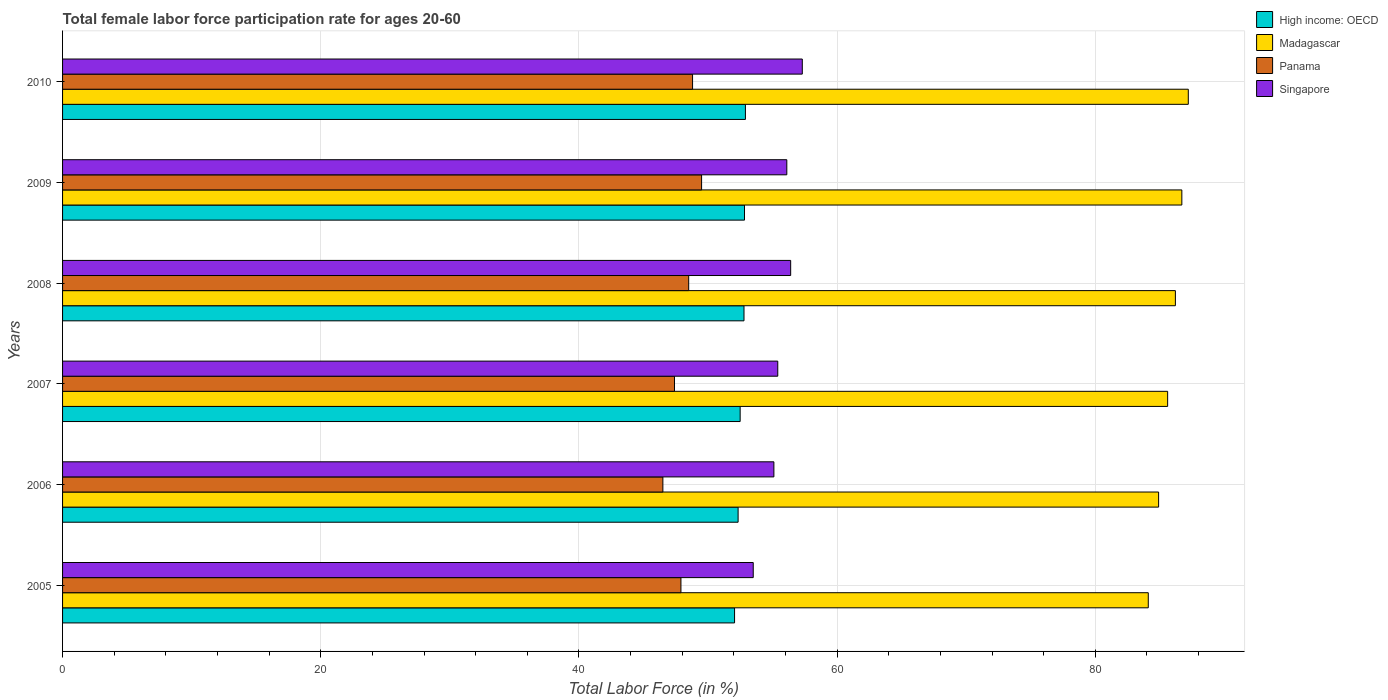How many different coloured bars are there?
Provide a succinct answer. 4. Are the number of bars on each tick of the Y-axis equal?
Provide a succinct answer. Yes. How many bars are there on the 6th tick from the bottom?
Keep it short and to the point. 4. In how many cases, is the number of bars for a given year not equal to the number of legend labels?
Provide a short and direct response. 0. What is the female labor force participation rate in Panama in 2008?
Your response must be concise. 48.5. Across all years, what is the maximum female labor force participation rate in Madagascar?
Offer a very short reply. 87.2. Across all years, what is the minimum female labor force participation rate in High income: OECD?
Give a very brief answer. 52.05. In which year was the female labor force participation rate in Madagascar maximum?
Make the answer very short. 2010. In which year was the female labor force participation rate in Madagascar minimum?
Your response must be concise. 2005. What is the total female labor force participation rate in Panama in the graph?
Your response must be concise. 288.6. What is the difference between the female labor force participation rate in Madagascar in 2006 and that in 2007?
Your answer should be very brief. -0.7. What is the difference between the female labor force participation rate in High income: OECD in 2006 and the female labor force participation rate in Singapore in 2008?
Provide a short and direct response. -4.07. What is the average female labor force participation rate in Madagascar per year?
Offer a terse response. 85.78. In the year 2006, what is the difference between the female labor force participation rate in Madagascar and female labor force participation rate in Singapore?
Your response must be concise. 29.8. What is the ratio of the female labor force participation rate in High income: OECD in 2005 to that in 2007?
Your answer should be compact. 0.99. Is the difference between the female labor force participation rate in Madagascar in 2005 and 2008 greater than the difference between the female labor force participation rate in Singapore in 2005 and 2008?
Your answer should be very brief. Yes. What is the difference between the highest and the second highest female labor force participation rate in Panama?
Your answer should be compact. 0.7. What does the 1st bar from the top in 2008 represents?
Your response must be concise. Singapore. What does the 3rd bar from the bottom in 2006 represents?
Your answer should be very brief. Panama. Is it the case that in every year, the sum of the female labor force participation rate in Singapore and female labor force participation rate in Madagascar is greater than the female labor force participation rate in Panama?
Provide a succinct answer. Yes. How many bars are there?
Your answer should be very brief. 24. How many years are there in the graph?
Offer a very short reply. 6. Does the graph contain any zero values?
Ensure brevity in your answer.  No. Where does the legend appear in the graph?
Offer a very short reply. Top right. How many legend labels are there?
Your response must be concise. 4. How are the legend labels stacked?
Keep it short and to the point. Vertical. What is the title of the graph?
Offer a very short reply. Total female labor force participation rate for ages 20-60. What is the label or title of the X-axis?
Your answer should be compact. Total Labor Force (in %). What is the label or title of the Y-axis?
Make the answer very short. Years. What is the Total Labor Force (in %) of High income: OECD in 2005?
Keep it short and to the point. 52.05. What is the Total Labor Force (in %) in Madagascar in 2005?
Give a very brief answer. 84.1. What is the Total Labor Force (in %) in Panama in 2005?
Give a very brief answer. 47.9. What is the Total Labor Force (in %) in Singapore in 2005?
Provide a short and direct response. 53.5. What is the Total Labor Force (in %) of High income: OECD in 2006?
Ensure brevity in your answer.  52.33. What is the Total Labor Force (in %) in Madagascar in 2006?
Make the answer very short. 84.9. What is the Total Labor Force (in %) of Panama in 2006?
Offer a terse response. 46.5. What is the Total Labor Force (in %) in Singapore in 2006?
Make the answer very short. 55.1. What is the Total Labor Force (in %) of High income: OECD in 2007?
Ensure brevity in your answer.  52.49. What is the Total Labor Force (in %) of Madagascar in 2007?
Ensure brevity in your answer.  85.6. What is the Total Labor Force (in %) of Panama in 2007?
Offer a very short reply. 47.4. What is the Total Labor Force (in %) in Singapore in 2007?
Give a very brief answer. 55.4. What is the Total Labor Force (in %) of High income: OECD in 2008?
Provide a short and direct response. 52.78. What is the Total Labor Force (in %) in Madagascar in 2008?
Offer a very short reply. 86.2. What is the Total Labor Force (in %) in Panama in 2008?
Ensure brevity in your answer.  48.5. What is the Total Labor Force (in %) in Singapore in 2008?
Give a very brief answer. 56.4. What is the Total Labor Force (in %) of High income: OECD in 2009?
Keep it short and to the point. 52.82. What is the Total Labor Force (in %) of Madagascar in 2009?
Your response must be concise. 86.7. What is the Total Labor Force (in %) of Panama in 2009?
Offer a terse response. 49.5. What is the Total Labor Force (in %) of Singapore in 2009?
Provide a short and direct response. 56.1. What is the Total Labor Force (in %) in High income: OECD in 2010?
Keep it short and to the point. 52.89. What is the Total Labor Force (in %) in Madagascar in 2010?
Provide a succinct answer. 87.2. What is the Total Labor Force (in %) of Panama in 2010?
Your answer should be compact. 48.8. What is the Total Labor Force (in %) in Singapore in 2010?
Offer a very short reply. 57.3. Across all years, what is the maximum Total Labor Force (in %) in High income: OECD?
Make the answer very short. 52.89. Across all years, what is the maximum Total Labor Force (in %) of Madagascar?
Offer a terse response. 87.2. Across all years, what is the maximum Total Labor Force (in %) of Panama?
Make the answer very short. 49.5. Across all years, what is the maximum Total Labor Force (in %) in Singapore?
Offer a very short reply. 57.3. Across all years, what is the minimum Total Labor Force (in %) of High income: OECD?
Your answer should be compact. 52.05. Across all years, what is the minimum Total Labor Force (in %) in Madagascar?
Give a very brief answer. 84.1. Across all years, what is the minimum Total Labor Force (in %) in Panama?
Offer a terse response. 46.5. Across all years, what is the minimum Total Labor Force (in %) of Singapore?
Provide a succinct answer. 53.5. What is the total Total Labor Force (in %) in High income: OECD in the graph?
Provide a short and direct response. 315.37. What is the total Total Labor Force (in %) in Madagascar in the graph?
Provide a succinct answer. 514.7. What is the total Total Labor Force (in %) in Panama in the graph?
Offer a very short reply. 288.6. What is the total Total Labor Force (in %) of Singapore in the graph?
Offer a very short reply. 333.8. What is the difference between the Total Labor Force (in %) of High income: OECD in 2005 and that in 2006?
Your answer should be compact. -0.27. What is the difference between the Total Labor Force (in %) in Madagascar in 2005 and that in 2006?
Give a very brief answer. -0.8. What is the difference between the Total Labor Force (in %) in Singapore in 2005 and that in 2006?
Offer a very short reply. -1.6. What is the difference between the Total Labor Force (in %) in High income: OECD in 2005 and that in 2007?
Your answer should be very brief. -0.43. What is the difference between the Total Labor Force (in %) of Madagascar in 2005 and that in 2007?
Offer a terse response. -1.5. What is the difference between the Total Labor Force (in %) in Panama in 2005 and that in 2007?
Your answer should be very brief. 0.5. What is the difference between the Total Labor Force (in %) of High income: OECD in 2005 and that in 2008?
Your response must be concise. -0.73. What is the difference between the Total Labor Force (in %) of Madagascar in 2005 and that in 2008?
Offer a very short reply. -2.1. What is the difference between the Total Labor Force (in %) of Panama in 2005 and that in 2008?
Offer a terse response. -0.6. What is the difference between the Total Labor Force (in %) of High income: OECD in 2005 and that in 2009?
Give a very brief answer. -0.77. What is the difference between the Total Labor Force (in %) in Madagascar in 2005 and that in 2009?
Offer a very short reply. -2.6. What is the difference between the Total Labor Force (in %) of Panama in 2005 and that in 2009?
Your answer should be compact. -1.6. What is the difference between the Total Labor Force (in %) of Singapore in 2005 and that in 2009?
Offer a very short reply. -2.6. What is the difference between the Total Labor Force (in %) of High income: OECD in 2005 and that in 2010?
Provide a short and direct response. -0.84. What is the difference between the Total Labor Force (in %) in Singapore in 2005 and that in 2010?
Provide a short and direct response. -3.8. What is the difference between the Total Labor Force (in %) of High income: OECD in 2006 and that in 2007?
Make the answer very short. -0.16. What is the difference between the Total Labor Force (in %) in High income: OECD in 2006 and that in 2008?
Keep it short and to the point. -0.46. What is the difference between the Total Labor Force (in %) of Madagascar in 2006 and that in 2008?
Ensure brevity in your answer.  -1.3. What is the difference between the Total Labor Force (in %) in Singapore in 2006 and that in 2008?
Your answer should be very brief. -1.3. What is the difference between the Total Labor Force (in %) in High income: OECD in 2006 and that in 2009?
Make the answer very short. -0.5. What is the difference between the Total Labor Force (in %) in Singapore in 2006 and that in 2009?
Offer a very short reply. -1. What is the difference between the Total Labor Force (in %) in High income: OECD in 2006 and that in 2010?
Offer a terse response. -0.57. What is the difference between the Total Labor Force (in %) of Madagascar in 2006 and that in 2010?
Make the answer very short. -2.3. What is the difference between the Total Labor Force (in %) in High income: OECD in 2007 and that in 2008?
Ensure brevity in your answer.  -0.3. What is the difference between the Total Labor Force (in %) of Madagascar in 2007 and that in 2008?
Offer a terse response. -0.6. What is the difference between the Total Labor Force (in %) in High income: OECD in 2007 and that in 2009?
Your answer should be compact. -0.34. What is the difference between the Total Labor Force (in %) of Singapore in 2007 and that in 2009?
Keep it short and to the point. -0.7. What is the difference between the Total Labor Force (in %) of High income: OECD in 2007 and that in 2010?
Make the answer very short. -0.41. What is the difference between the Total Labor Force (in %) in Panama in 2007 and that in 2010?
Your answer should be compact. -1.4. What is the difference between the Total Labor Force (in %) of High income: OECD in 2008 and that in 2009?
Provide a short and direct response. -0.04. What is the difference between the Total Labor Force (in %) of Madagascar in 2008 and that in 2009?
Keep it short and to the point. -0.5. What is the difference between the Total Labor Force (in %) of Panama in 2008 and that in 2009?
Give a very brief answer. -1. What is the difference between the Total Labor Force (in %) in Singapore in 2008 and that in 2009?
Offer a terse response. 0.3. What is the difference between the Total Labor Force (in %) in High income: OECD in 2008 and that in 2010?
Your answer should be very brief. -0.11. What is the difference between the Total Labor Force (in %) in Singapore in 2008 and that in 2010?
Your answer should be compact. -0.9. What is the difference between the Total Labor Force (in %) in High income: OECD in 2009 and that in 2010?
Give a very brief answer. -0.07. What is the difference between the Total Labor Force (in %) in Panama in 2009 and that in 2010?
Offer a very short reply. 0.7. What is the difference between the Total Labor Force (in %) of High income: OECD in 2005 and the Total Labor Force (in %) of Madagascar in 2006?
Make the answer very short. -32.85. What is the difference between the Total Labor Force (in %) of High income: OECD in 2005 and the Total Labor Force (in %) of Panama in 2006?
Make the answer very short. 5.55. What is the difference between the Total Labor Force (in %) in High income: OECD in 2005 and the Total Labor Force (in %) in Singapore in 2006?
Give a very brief answer. -3.05. What is the difference between the Total Labor Force (in %) in Madagascar in 2005 and the Total Labor Force (in %) in Panama in 2006?
Ensure brevity in your answer.  37.6. What is the difference between the Total Labor Force (in %) in Panama in 2005 and the Total Labor Force (in %) in Singapore in 2006?
Your answer should be compact. -7.2. What is the difference between the Total Labor Force (in %) in High income: OECD in 2005 and the Total Labor Force (in %) in Madagascar in 2007?
Provide a succinct answer. -33.55. What is the difference between the Total Labor Force (in %) in High income: OECD in 2005 and the Total Labor Force (in %) in Panama in 2007?
Keep it short and to the point. 4.65. What is the difference between the Total Labor Force (in %) of High income: OECD in 2005 and the Total Labor Force (in %) of Singapore in 2007?
Offer a very short reply. -3.35. What is the difference between the Total Labor Force (in %) of Madagascar in 2005 and the Total Labor Force (in %) of Panama in 2007?
Ensure brevity in your answer.  36.7. What is the difference between the Total Labor Force (in %) of Madagascar in 2005 and the Total Labor Force (in %) of Singapore in 2007?
Provide a succinct answer. 28.7. What is the difference between the Total Labor Force (in %) in High income: OECD in 2005 and the Total Labor Force (in %) in Madagascar in 2008?
Give a very brief answer. -34.15. What is the difference between the Total Labor Force (in %) of High income: OECD in 2005 and the Total Labor Force (in %) of Panama in 2008?
Your response must be concise. 3.55. What is the difference between the Total Labor Force (in %) in High income: OECD in 2005 and the Total Labor Force (in %) in Singapore in 2008?
Your answer should be compact. -4.35. What is the difference between the Total Labor Force (in %) of Madagascar in 2005 and the Total Labor Force (in %) of Panama in 2008?
Give a very brief answer. 35.6. What is the difference between the Total Labor Force (in %) in Madagascar in 2005 and the Total Labor Force (in %) in Singapore in 2008?
Ensure brevity in your answer.  27.7. What is the difference between the Total Labor Force (in %) in Panama in 2005 and the Total Labor Force (in %) in Singapore in 2008?
Ensure brevity in your answer.  -8.5. What is the difference between the Total Labor Force (in %) of High income: OECD in 2005 and the Total Labor Force (in %) of Madagascar in 2009?
Your answer should be compact. -34.65. What is the difference between the Total Labor Force (in %) of High income: OECD in 2005 and the Total Labor Force (in %) of Panama in 2009?
Your answer should be compact. 2.55. What is the difference between the Total Labor Force (in %) of High income: OECD in 2005 and the Total Labor Force (in %) of Singapore in 2009?
Provide a succinct answer. -4.05. What is the difference between the Total Labor Force (in %) in Madagascar in 2005 and the Total Labor Force (in %) in Panama in 2009?
Your response must be concise. 34.6. What is the difference between the Total Labor Force (in %) of Madagascar in 2005 and the Total Labor Force (in %) of Singapore in 2009?
Give a very brief answer. 28. What is the difference between the Total Labor Force (in %) of High income: OECD in 2005 and the Total Labor Force (in %) of Madagascar in 2010?
Your answer should be compact. -35.15. What is the difference between the Total Labor Force (in %) of High income: OECD in 2005 and the Total Labor Force (in %) of Panama in 2010?
Offer a terse response. 3.25. What is the difference between the Total Labor Force (in %) in High income: OECD in 2005 and the Total Labor Force (in %) in Singapore in 2010?
Offer a terse response. -5.25. What is the difference between the Total Labor Force (in %) of Madagascar in 2005 and the Total Labor Force (in %) of Panama in 2010?
Your response must be concise. 35.3. What is the difference between the Total Labor Force (in %) in Madagascar in 2005 and the Total Labor Force (in %) in Singapore in 2010?
Provide a short and direct response. 26.8. What is the difference between the Total Labor Force (in %) in High income: OECD in 2006 and the Total Labor Force (in %) in Madagascar in 2007?
Provide a succinct answer. -33.27. What is the difference between the Total Labor Force (in %) in High income: OECD in 2006 and the Total Labor Force (in %) in Panama in 2007?
Your answer should be compact. 4.93. What is the difference between the Total Labor Force (in %) in High income: OECD in 2006 and the Total Labor Force (in %) in Singapore in 2007?
Your answer should be very brief. -3.07. What is the difference between the Total Labor Force (in %) of Madagascar in 2006 and the Total Labor Force (in %) of Panama in 2007?
Make the answer very short. 37.5. What is the difference between the Total Labor Force (in %) in Madagascar in 2006 and the Total Labor Force (in %) in Singapore in 2007?
Your answer should be compact. 29.5. What is the difference between the Total Labor Force (in %) in High income: OECD in 2006 and the Total Labor Force (in %) in Madagascar in 2008?
Your answer should be compact. -33.87. What is the difference between the Total Labor Force (in %) of High income: OECD in 2006 and the Total Labor Force (in %) of Panama in 2008?
Your answer should be very brief. 3.83. What is the difference between the Total Labor Force (in %) of High income: OECD in 2006 and the Total Labor Force (in %) of Singapore in 2008?
Offer a terse response. -4.07. What is the difference between the Total Labor Force (in %) in Madagascar in 2006 and the Total Labor Force (in %) in Panama in 2008?
Your answer should be very brief. 36.4. What is the difference between the Total Labor Force (in %) of High income: OECD in 2006 and the Total Labor Force (in %) of Madagascar in 2009?
Your answer should be compact. -34.37. What is the difference between the Total Labor Force (in %) of High income: OECD in 2006 and the Total Labor Force (in %) of Panama in 2009?
Give a very brief answer. 2.83. What is the difference between the Total Labor Force (in %) in High income: OECD in 2006 and the Total Labor Force (in %) in Singapore in 2009?
Ensure brevity in your answer.  -3.77. What is the difference between the Total Labor Force (in %) in Madagascar in 2006 and the Total Labor Force (in %) in Panama in 2009?
Ensure brevity in your answer.  35.4. What is the difference between the Total Labor Force (in %) of Madagascar in 2006 and the Total Labor Force (in %) of Singapore in 2009?
Keep it short and to the point. 28.8. What is the difference between the Total Labor Force (in %) in High income: OECD in 2006 and the Total Labor Force (in %) in Madagascar in 2010?
Keep it short and to the point. -34.87. What is the difference between the Total Labor Force (in %) of High income: OECD in 2006 and the Total Labor Force (in %) of Panama in 2010?
Provide a succinct answer. 3.53. What is the difference between the Total Labor Force (in %) in High income: OECD in 2006 and the Total Labor Force (in %) in Singapore in 2010?
Your answer should be very brief. -4.97. What is the difference between the Total Labor Force (in %) of Madagascar in 2006 and the Total Labor Force (in %) of Panama in 2010?
Keep it short and to the point. 36.1. What is the difference between the Total Labor Force (in %) in Madagascar in 2006 and the Total Labor Force (in %) in Singapore in 2010?
Your response must be concise. 27.6. What is the difference between the Total Labor Force (in %) of Panama in 2006 and the Total Labor Force (in %) of Singapore in 2010?
Keep it short and to the point. -10.8. What is the difference between the Total Labor Force (in %) of High income: OECD in 2007 and the Total Labor Force (in %) of Madagascar in 2008?
Your response must be concise. -33.71. What is the difference between the Total Labor Force (in %) of High income: OECD in 2007 and the Total Labor Force (in %) of Panama in 2008?
Make the answer very short. 3.99. What is the difference between the Total Labor Force (in %) of High income: OECD in 2007 and the Total Labor Force (in %) of Singapore in 2008?
Give a very brief answer. -3.91. What is the difference between the Total Labor Force (in %) of Madagascar in 2007 and the Total Labor Force (in %) of Panama in 2008?
Your answer should be very brief. 37.1. What is the difference between the Total Labor Force (in %) of Madagascar in 2007 and the Total Labor Force (in %) of Singapore in 2008?
Provide a short and direct response. 29.2. What is the difference between the Total Labor Force (in %) in Panama in 2007 and the Total Labor Force (in %) in Singapore in 2008?
Provide a short and direct response. -9. What is the difference between the Total Labor Force (in %) in High income: OECD in 2007 and the Total Labor Force (in %) in Madagascar in 2009?
Give a very brief answer. -34.21. What is the difference between the Total Labor Force (in %) of High income: OECD in 2007 and the Total Labor Force (in %) of Panama in 2009?
Provide a short and direct response. 2.99. What is the difference between the Total Labor Force (in %) in High income: OECD in 2007 and the Total Labor Force (in %) in Singapore in 2009?
Offer a very short reply. -3.61. What is the difference between the Total Labor Force (in %) of Madagascar in 2007 and the Total Labor Force (in %) of Panama in 2009?
Ensure brevity in your answer.  36.1. What is the difference between the Total Labor Force (in %) in Madagascar in 2007 and the Total Labor Force (in %) in Singapore in 2009?
Offer a very short reply. 29.5. What is the difference between the Total Labor Force (in %) in High income: OECD in 2007 and the Total Labor Force (in %) in Madagascar in 2010?
Provide a short and direct response. -34.71. What is the difference between the Total Labor Force (in %) in High income: OECD in 2007 and the Total Labor Force (in %) in Panama in 2010?
Your response must be concise. 3.69. What is the difference between the Total Labor Force (in %) of High income: OECD in 2007 and the Total Labor Force (in %) of Singapore in 2010?
Ensure brevity in your answer.  -4.81. What is the difference between the Total Labor Force (in %) in Madagascar in 2007 and the Total Labor Force (in %) in Panama in 2010?
Your response must be concise. 36.8. What is the difference between the Total Labor Force (in %) of Madagascar in 2007 and the Total Labor Force (in %) of Singapore in 2010?
Give a very brief answer. 28.3. What is the difference between the Total Labor Force (in %) in Panama in 2007 and the Total Labor Force (in %) in Singapore in 2010?
Provide a succinct answer. -9.9. What is the difference between the Total Labor Force (in %) in High income: OECD in 2008 and the Total Labor Force (in %) in Madagascar in 2009?
Provide a short and direct response. -33.92. What is the difference between the Total Labor Force (in %) of High income: OECD in 2008 and the Total Labor Force (in %) of Panama in 2009?
Your answer should be compact. 3.28. What is the difference between the Total Labor Force (in %) in High income: OECD in 2008 and the Total Labor Force (in %) in Singapore in 2009?
Provide a short and direct response. -3.32. What is the difference between the Total Labor Force (in %) in Madagascar in 2008 and the Total Labor Force (in %) in Panama in 2009?
Your response must be concise. 36.7. What is the difference between the Total Labor Force (in %) in Madagascar in 2008 and the Total Labor Force (in %) in Singapore in 2009?
Offer a very short reply. 30.1. What is the difference between the Total Labor Force (in %) of Panama in 2008 and the Total Labor Force (in %) of Singapore in 2009?
Give a very brief answer. -7.6. What is the difference between the Total Labor Force (in %) of High income: OECD in 2008 and the Total Labor Force (in %) of Madagascar in 2010?
Offer a very short reply. -34.42. What is the difference between the Total Labor Force (in %) in High income: OECD in 2008 and the Total Labor Force (in %) in Panama in 2010?
Provide a short and direct response. 3.98. What is the difference between the Total Labor Force (in %) in High income: OECD in 2008 and the Total Labor Force (in %) in Singapore in 2010?
Make the answer very short. -4.52. What is the difference between the Total Labor Force (in %) of Madagascar in 2008 and the Total Labor Force (in %) of Panama in 2010?
Offer a terse response. 37.4. What is the difference between the Total Labor Force (in %) in Madagascar in 2008 and the Total Labor Force (in %) in Singapore in 2010?
Make the answer very short. 28.9. What is the difference between the Total Labor Force (in %) of High income: OECD in 2009 and the Total Labor Force (in %) of Madagascar in 2010?
Ensure brevity in your answer.  -34.38. What is the difference between the Total Labor Force (in %) of High income: OECD in 2009 and the Total Labor Force (in %) of Panama in 2010?
Offer a terse response. 4.02. What is the difference between the Total Labor Force (in %) in High income: OECD in 2009 and the Total Labor Force (in %) in Singapore in 2010?
Your answer should be compact. -4.48. What is the difference between the Total Labor Force (in %) of Madagascar in 2009 and the Total Labor Force (in %) of Panama in 2010?
Keep it short and to the point. 37.9. What is the difference between the Total Labor Force (in %) of Madagascar in 2009 and the Total Labor Force (in %) of Singapore in 2010?
Make the answer very short. 29.4. What is the difference between the Total Labor Force (in %) of Panama in 2009 and the Total Labor Force (in %) of Singapore in 2010?
Offer a very short reply. -7.8. What is the average Total Labor Force (in %) of High income: OECD per year?
Your answer should be very brief. 52.56. What is the average Total Labor Force (in %) of Madagascar per year?
Provide a short and direct response. 85.78. What is the average Total Labor Force (in %) of Panama per year?
Your response must be concise. 48.1. What is the average Total Labor Force (in %) in Singapore per year?
Ensure brevity in your answer.  55.63. In the year 2005, what is the difference between the Total Labor Force (in %) of High income: OECD and Total Labor Force (in %) of Madagascar?
Make the answer very short. -32.05. In the year 2005, what is the difference between the Total Labor Force (in %) in High income: OECD and Total Labor Force (in %) in Panama?
Provide a succinct answer. 4.15. In the year 2005, what is the difference between the Total Labor Force (in %) of High income: OECD and Total Labor Force (in %) of Singapore?
Offer a very short reply. -1.45. In the year 2005, what is the difference between the Total Labor Force (in %) of Madagascar and Total Labor Force (in %) of Panama?
Your answer should be compact. 36.2. In the year 2005, what is the difference between the Total Labor Force (in %) of Madagascar and Total Labor Force (in %) of Singapore?
Keep it short and to the point. 30.6. In the year 2005, what is the difference between the Total Labor Force (in %) of Panama and Total Labor Force (in %) of Singapore?
Keep it short and to the point. -5.6. In the year 2006, what is the difference between the Total Labor Force (in %) in High income: OECD and Total Labor Force (in %) in Madagascar?
Your answer should be very brief. -32.57. In the year 2006, what is the difference between the Total Labor Force (in %) of High income: OECD and Total Labor Force (in %) of Panama?
Your response must be concise. 5.83. In the year 2006, what is the difference between the Total Labor Force (in %) in High income: OECD and Total Labor Force (in %) in Singapore?
Your response must be concise. -2.77. In the year 2006, what is the difference between the Total Labor Force (in %) in Madagascar and Total Labor Force (in %) in Panama?
Ensure brevity in your answer.  38.4. In the year 2006, what is the difference between the Total Labor Force (in %) in Madagascar and Total Labor Force (in %) in Singapore?
Offer a very short reply. 29.8. In the year 2006, what is the difference between the Total Labor Force (in %) of Panama and Total Labor Force (in %) of Singapore?
Your answer should be very brief. -8.6. In the year 2007, what is the difference between the Total Labor Force (in %) in High income: OECD and Total Labor Force (in %) in Madagascar?
Give a very brief answer. -33.11. In the year 2007, what is the difference between the Total Labor Force (in %) in High income: OECD and Total Labor Force (in %) in Panama?
Offer a very short reply. 5.09. In the year 2007, what is the difference between the Total Labor Force (in %) of High income: OECD and Total Labor Force (in %) of Singapore?
Offer a terse response. -2.91. In the year 2007, what is the difference between the Total Labor Force (in %) of Madagascar and Total Labor Force (in %) of Panama?
Make the answer very short. 38.2. In the year 2007, what is the difference between the Total Labor Force (in %) in Madagascar and Total Labor Force (in %) in Singapore?
Your answer should be very brief. 30.2. In the year 2008, what is the difference between the Total Labor Force (in %) of High income: OECD and Total Labor Force (in %) of Madagascar?
Offer a terse response. -33.42. In the year 2008, what is the difference between the Total Labor Force (in %) in High income: OECD and Total Labor Force (in %) in Panama?
Offer a terse response. 4.28. In the year 2008, what is the difference between the Total Labor Force (in %) in High income: OECD and Total Labor Force (in %) in Singapore?
Your answer should be compact. -3.62. In the year 2008, what is the difference between the Total Labor Force (in %) of Madagascar and Total Labor Force (in %) of Panama?
Provide a short and direct response. 37.7. In the year 2008, what is the difference between the Total Labor Force (in %) in Madagascar and Total Labor Force (in %) in Singapore?
Your answer should be very brief. 29.8. In the year 2009, what is the difference between the Total Labor Force (in %) in High income: OECD and Total Labor Force (in %) in Madagascar?
Make the answer very short. -33.88. In the year 2009, what is the difference between the Total Labor Force (in %) of High income: OECD and Total Labor Force (in %) of Panama?
Offer a very short reply. 3.32. In the year 2009, what is the difference between the Total Labor Force (in %) of High income: OECD and Total Labor Force (in %) of Singapore?
Provide a succinct answer. -3.28. In the year 2009, what is the difference between the Total Labor Force (in %) in Madagascar and Total Labor Force (in %) in Panama?
Ensure brevity in your answer.  37.2. In the year 2009, what is the difference between the Total Labor Force (in %) in Madagascar and Total Labor Force (in %) in Singapore?
Keep it short and to the point. 30.6. In the year 2009, what is the difference between the Total Labor Force (in %) in Panama and Total Labor Force (in %) in Singapore?
Offer a very short reply. -6.6. In the year 2010, what is the difference between the Total Labor Force (in %) in High income: OECD and Total Labor Force (in %) in Madagascar?
Give a very brief answer. -34.31. In the year 2010, what is the difference between the Total Labor Force (in %) of High income: OECD and Total Labor Force (in %) of Panama?
Provide a succinct answer. 4.09. In the year 2010, what is the difference between the Total Labor Force (in %) of High income: OECD and Total Labor Force (in %) of Singapore?
Provide a succinct answer. -4.41. In the year 2010, what is the difference between the Total Labor Force (in %) in Madagascar and Total Labor Force (in %) in Panama?
Offer a very short reply. 38.4. In the year 2010, what is the difference between the Total Labor Force (in %) in Madagascar and Total Labor Force (in %) in Singapore?
Provide a succinct answer. 29.9. What is the ratio of the Total Labor Force (in %) of High income: OECD in 2005 to that in 2006?
Provide a short and direct response. 0.99. What is the ratio of the Total Labor Force (in %) of Madagascar in 2005 to that in 2006?
Provide a succinct answer. 0.99. What is the ratio of the Total Labor Force (in %) of Panama in 2005 to that in 2006?
Your answer should be compact. 1.03. What is the ratio of the Total Labor Force (in %) of Singapore in 2005 to that in 2006?
Provide a succinct answer. 0.97. What is the ratio of the Total Labor Force (in %) in Madagascar in 2005 to that in 2007?
Provide a succinct answer. 0.98. What is the ratio of the Total Labor Force (in %) in Panama in 2005 to that in 2007?
Give a very brief answer. 1.01. What is the ratio of the Total Labor Force (in %) of Singapore in 2005 to that in 2007?
Offer a very short reply. 0.97. What is the ratio of the Total Labor Force (in %) in High income: OECD in 2005 to that in 2008?
Your answer should be very brief. 0.99. What is the ratio of the Total Labor Force (in %) of Madagascar in 2005 to that in 2008?
Your response must be concise. 0.98. What is the ratio of the Total Labor Force (in %) of Panama in 2005 to that in 2008?
Give a very brief answer. 0.99. What is the ratio of the Total Labor Force (in %) of Singapore in 2005 to that in 2008?
Offer a very short reply. 0.95. What is the ratio of the Total Labor Force (in %) in High income: OECD in 2005 to that in 2009?
Provide a succinct answer. 0.99. What is the ratio of the Total Labor Force (in %) in Madagascar in 2005 to that in 2009?
Offer a terse response. 0.97. What is the ratio of the Total Labor Force (in %) of Singapore in 2005 to that in 2009?
Your response must be concise. 0.95. What is the ratio of the Total Labor Force (in %) in High income: OECD in 2005 to that in 2010?
Your answer should be compact. 0.98. What is the ratio of the Total Labor Force (in %) of Madagascar in 2005 to that in 2010?
Make the answer very short. 0.96. What is the ratio of the Total Labor Force (in %) of Panama in 2005 to that in 2010?
Ensure brevity in your answer.  0.98. What is the ratio of the Total Labor Force (in %) of Singapore in 2005 to that in 2010?
Give a very brief answer. 0.93. What is the ratio of the Total Labor Force (in %) in Madagascar in 2006 to that in 2007?
Give a very brief answer. 0.99. What is the ratio of the Total Labor Force (in %) of Singapore in 2006 to that in 2007?
Your answer should be compact. 0.99. What is the ratio of the Total Labor Force (in %) of Madagascar in 2006 to that in 2008?
Keep it short and to the point. 0.98. What is the ratio of the Total Labor Force (in %) in Panama in 2006 to that in 2008?
Provide a short and direct response. 0.96. What is the ratio of the Total Labor Force (in %) in Singapore in 2006 to that in 2008?
Offer a very short reply. 0.98. What is the ratio of the Total Labor Force (in %) of High income: OECD in 2006 to that in 2009?
Your response must be concise. 0.99. What is the ratio of the Total Labor Force (in %) of Madagascar in 2006 to that in 2009?
Ensure brevity in your answer.  0.98. What is the ratio of the Total Labor Force (in %) in Panama in 2006 to that in 2009?
Give a very brief answer. 0.94. What is the ratio of the Total Labor Force (in %) in Singapore in 2006 to that in 2009?
Make the answer very short. 0.98. What is the ratio of the Total Labor Force (in %) in High income: OECD in 2006 to that in 2010?
Your answer should be very brief. 0.99. What is the ratio of the Total Labor Force (in %) of Madagascar in 2006 to that in 2010?
Give a very brief answer. 0.97. What is the ratio of the Total Labor Force (in %) of Panama in 2006 to that in 2010?
Keep it short and to the point. 0.95. What is the ratio of the Total Labor Force (in %) of Singapore in 2006 to that in 2010?
Your answer should be very brief. 0.96. What is the ratio of the Total Labor Force (in %) of Madagascar in 2007 to that in 2008?
Provide a succinct answer. 0.99. What is the ratio of the Total Labor Force (in %) of Panama in 2007 to that in 2008?
Make the answer very short. 0.98. What is the ratio of the Total Labor Force (in %) of Singapore in 2007 to that in 2008?
Your answer should be very brief. 0.98. What is the ratio of the Total Labor Force (in %) in Madagascar in 2007 to that in 2009?
Your answer should be very brief. 0.99. What is the ratio of the Total Labor Force (in %) in Panama in 2007 to that in 2009?
Offer a very short reply. 0.96. What is the ratio of the Total Labor Force (in %) of Singapore in 2007 to that in 2009?
Your answer should be compact. 0.99. What is the ratio of the Total Labor Force (in %) in High income: OECD in 2007 to that in 2010?
Give a very brief answer. 0.99. What is the ratio of the Total Labor Force (in %) in Madagascar in 2007 to that in 2010?
Keep it short and to the point. 0.98. What is the ratio of the Total Labor Force (in %) in Panama in 2007 to that in 2010?
Your response must be concise. 0.97. What is the ratio of the Total Labor Force (in %) in Singapore in 2007 to that in 2010?
Offer a very short reply. 0.97. What is the ratio of the Total Labor Force (in %) of Madagascar in 2008 to that in 2009?
Offer a terse response. 0.99. What is the ratio of the Total Labor Force (in %) in Panama in 2008 to that in 2009?
Your response must be concise. 0.98. What is the ratio of the Total Labor Force (in %) of Singapore in 2008 to that in 2009?
Your answer should be very brief. 1.01. What is the ratio of the Total Labor Force (in %) of High income: OECD in 2008 to that in 2010?
Provide a succinct answer. 1. What is the ratio of the Total Labor Force (in %) of Singapore in 2008 to that in 2010?
Give a very brief answer. 0.98. What is the ratio of the Total Labor Force (in %) in High income: OECD in 2009 to that in 2010?
Your answer should be compact. 1. What is the ratio of the Total Labor Force (in %) in Panama in 2009 to that in 2010?
Your answer should be very brief. 1.01. What is the ratio of the Total Labor Force (in %) of Singapore in 2009 to that in 2010?
Make the answer very short. 0.98. What is the difference between the highest and the second highest Total Labor Force (in %) in High income: OECD?
Provide a short and direct response. 0.07. What is the difference between the highest and the second highest Total Labor Force (in %) of Madagascar?
Your answer should be very brief. 0.5. What is the difference between the highest and the lowest Total Labor Force (in %) of High income: OECD?
Provide a short and direct response. 0.84. What is the difference between the highest and the lowest Total Labor Force (in %) in Madagascar?
Your response must be concise. 3.1. 